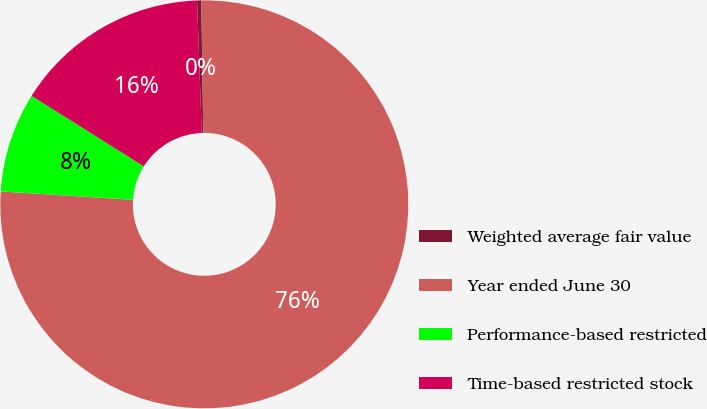Convert chart to OTSL. <chart><loc_0><loc_0><loc_500><loc_500><pie_chart><fcel>Weighted average fair value<fcel>Year ended June 30<fcel>Performance-based restricted<fcel>Time-based restricted stock<nl><fcel>0.33%<fcel>76.24%<fcel>7.92%<fcel>15.51%<nl></chart> 